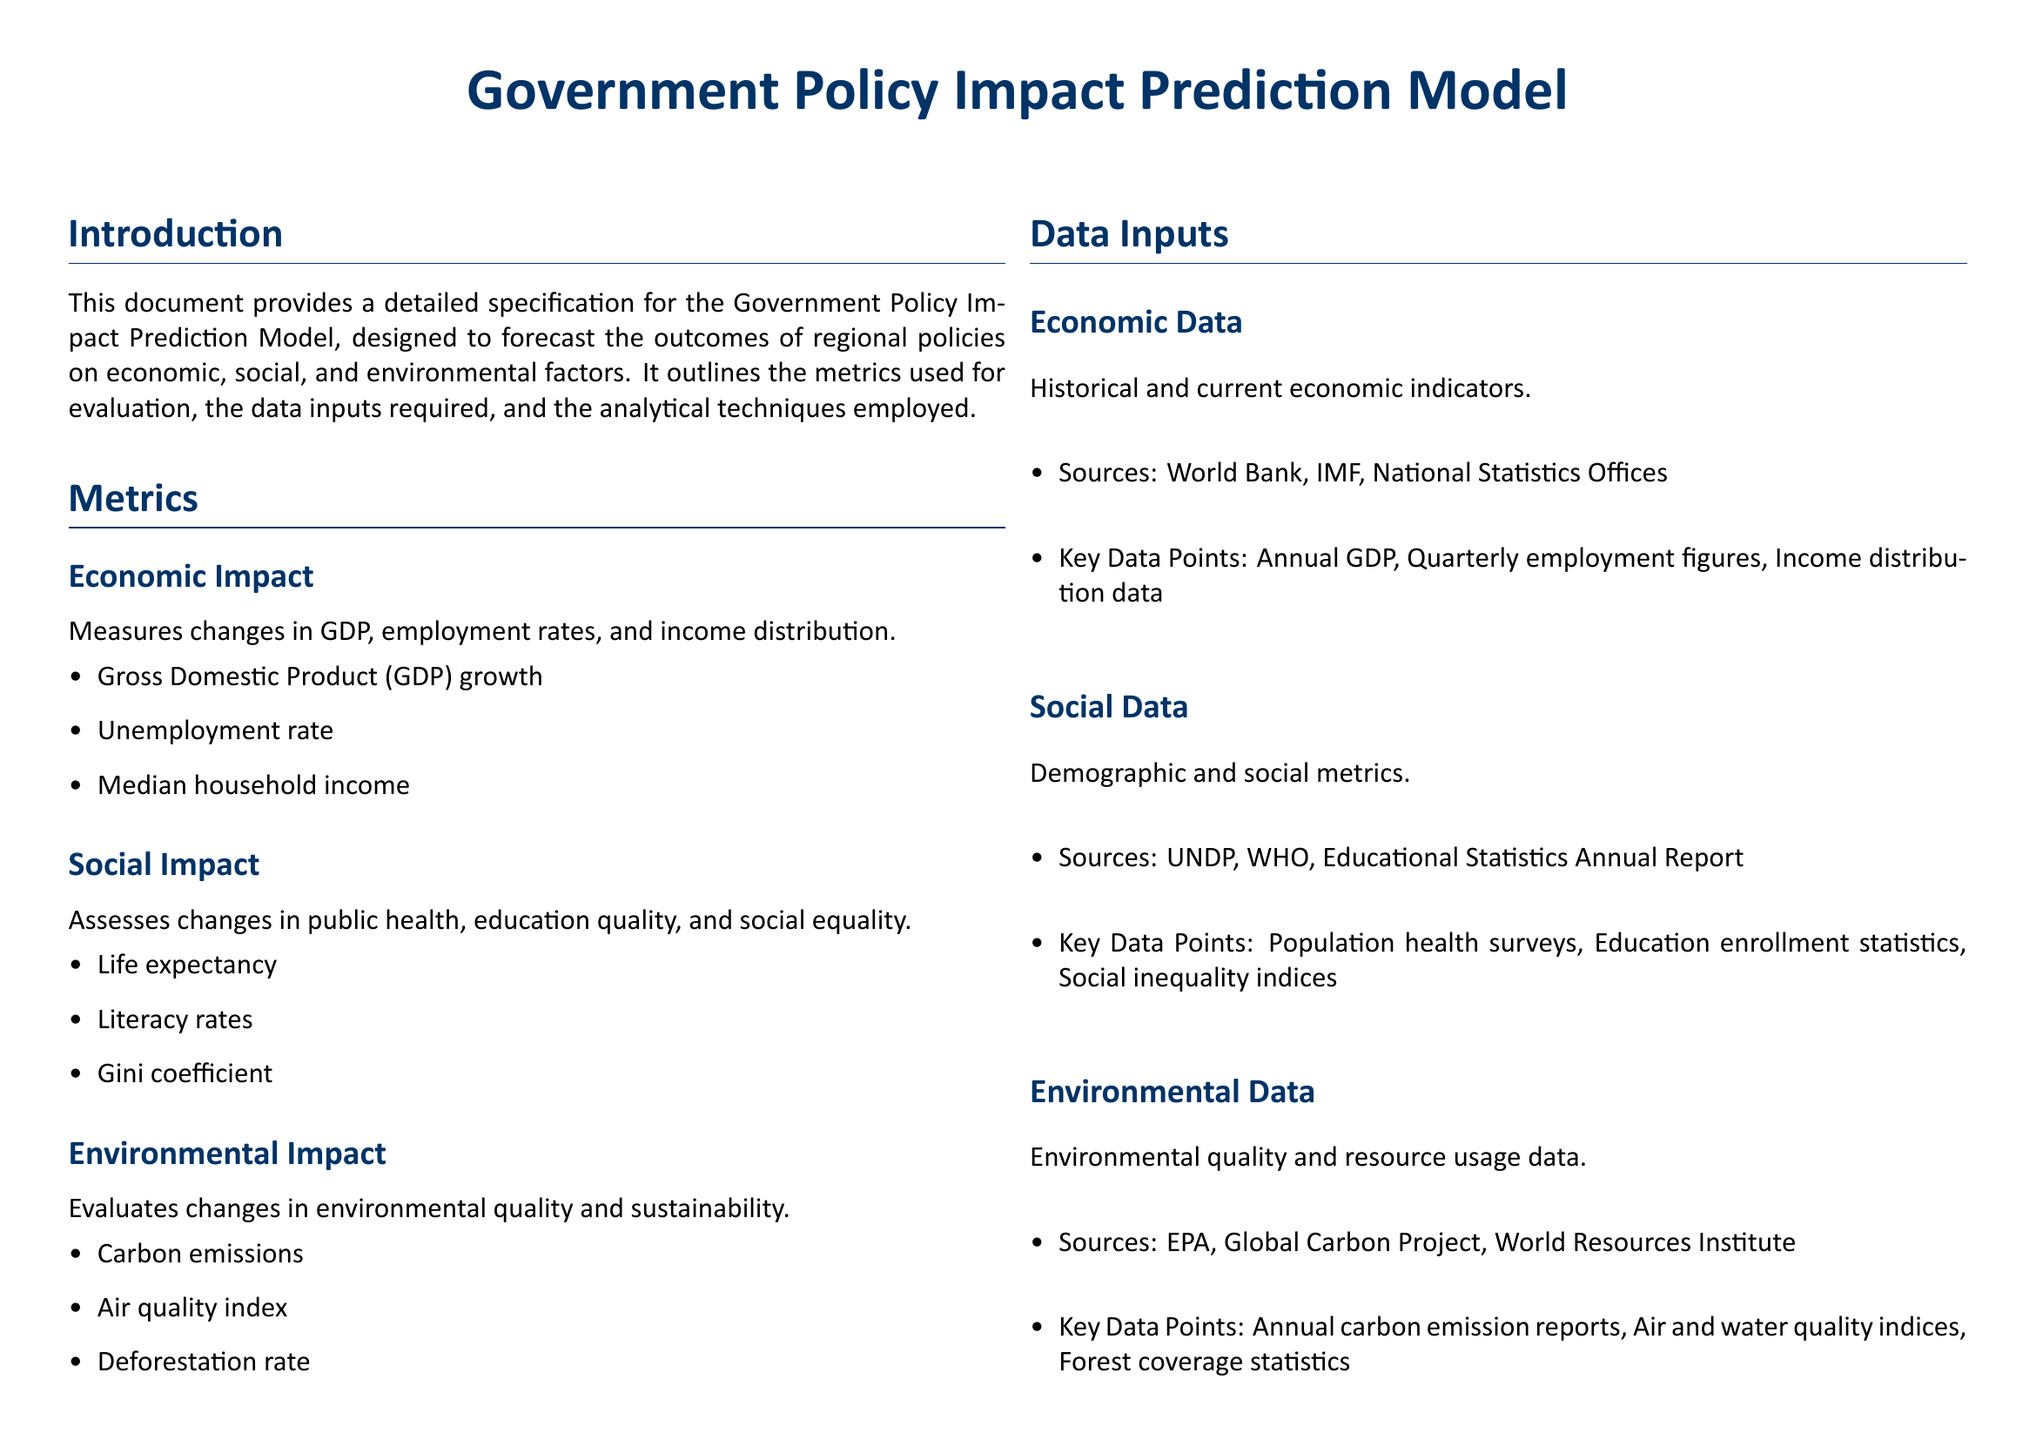What are the three types of impact measured? The document lists Economic, Social, and Environmental as the three types of impact measured.
Answer: Economic, Social, Environmental What sources are listed for economic data? The document specifies World Bank, IMF, and National Statistics Offices as the sources for economic data.
Answer: World Bank, IMF, National Statistics Offices What is one key data point for social data? The document states that Population health surveys are one key data point for social data.
Answer: Population health surveys How many analytical techniques are mentioned? The document enumerates three analytical techniques: Regression Analysis, Machine Learning, and Simulation Modeling.
Answer: Three What is the purpose of the Government Policy Impact Prediction Model? The document describes that the purpose is to forecast the outcomes of regional policies on economic, social, and environmental factors.
Answer: To forecast the outcomes of regional policies Which machine learning technique is mentioned first? The document lists Random Forest as the first machine learning technique mentioned.
Answer: Random Forest What metric is used to assess social equality? The Gini coefficient is the metric used to assess social equality, as specified in the document.
Answer: Gini coefficient Which environmental metric evaluates carbon emissions? The Carbon emissions metric evaluates changes in environmental quality and sustainability as stated in the document.
Answer: Carbon emissions 